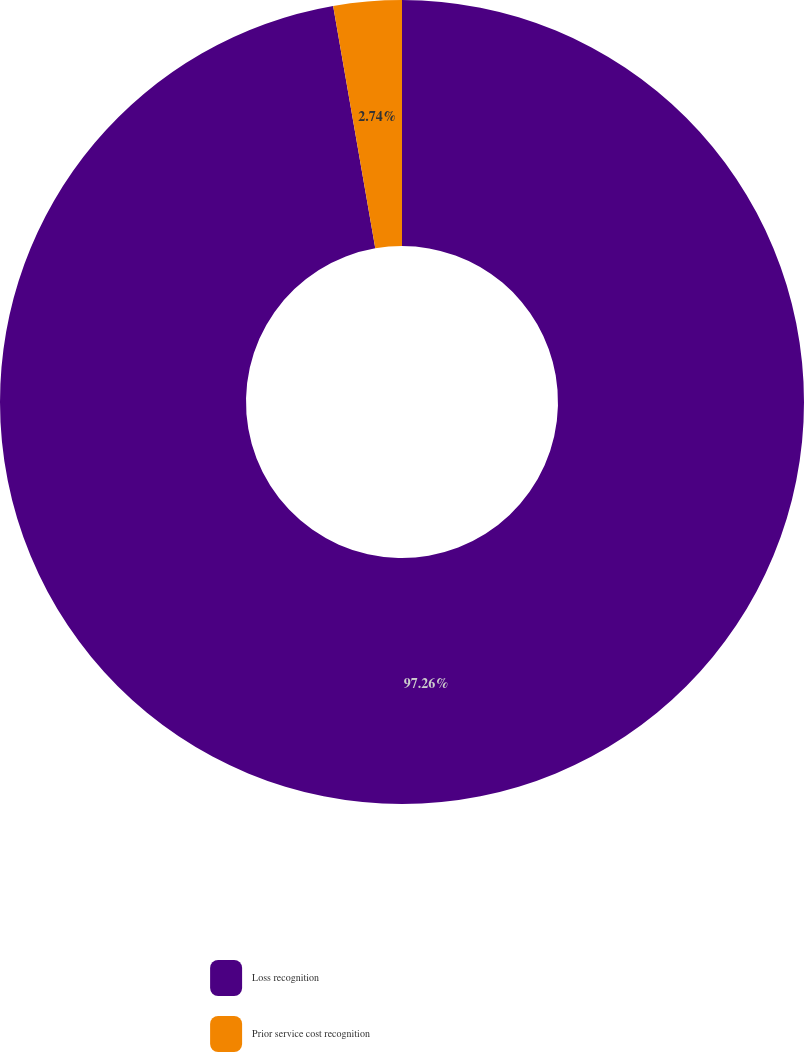Convert chart. <chart><loc_0><loc_0><loc_500><loc_500><pie_chart><fcel>Loss recognition<fcel>Prior service cost recognition<nl><fcel>97.26%<fcel>2.74%<nl></chart> 